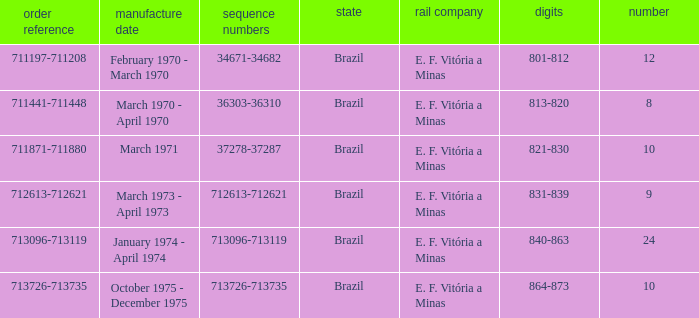What country has the order number 711871-711880? Brazil. 